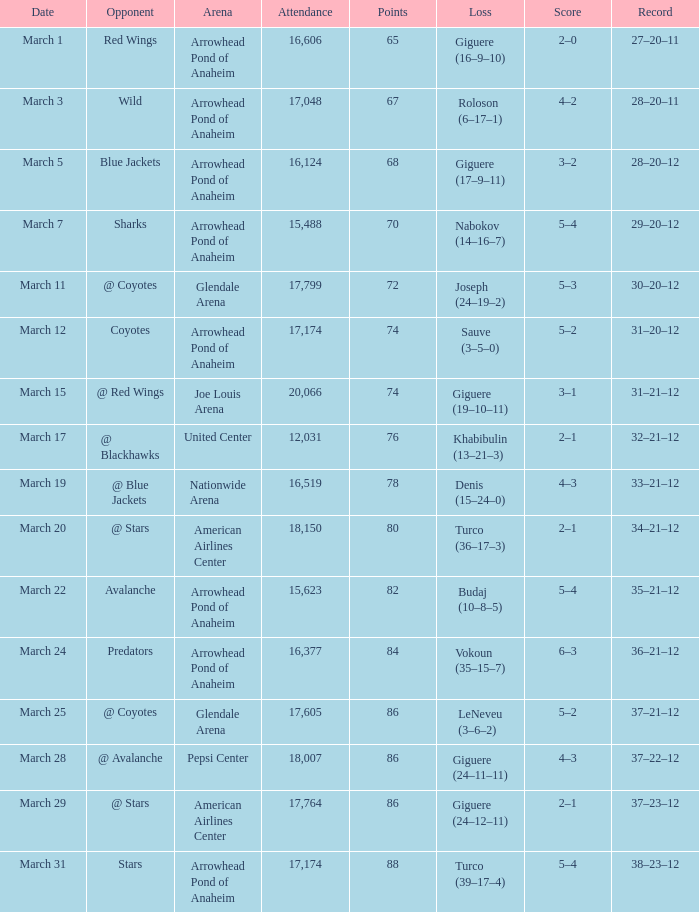What is the Attendance of the game with a Record of 37–21–12 and less than 86 Points? None. 